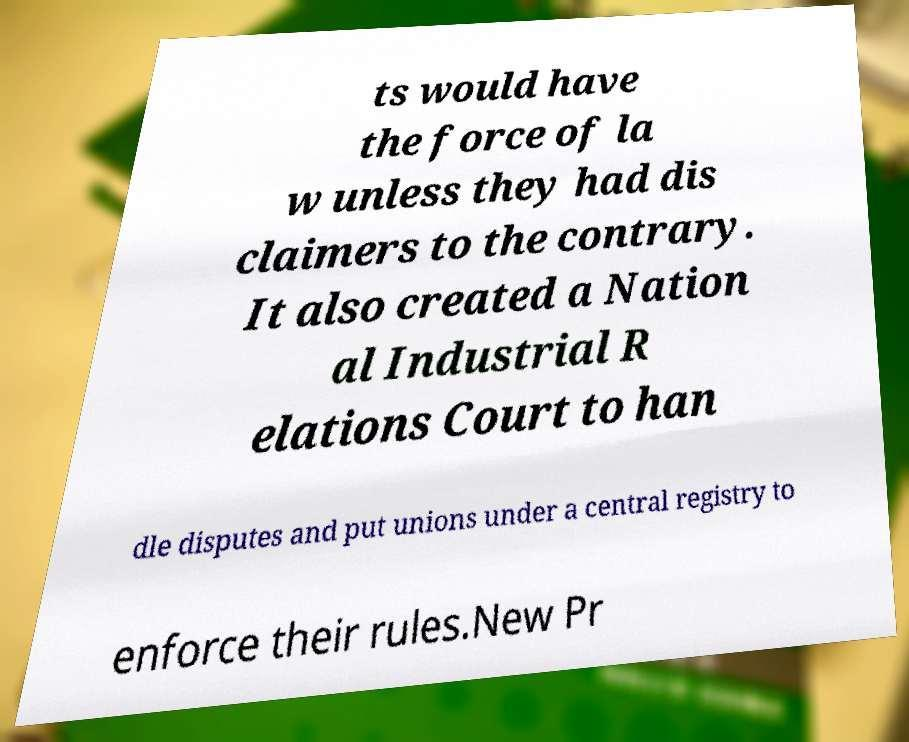Can you accurately transcribe the text from the provided image for me? ts would have the force of la w unless they had dis claimers to the contrary. It also created a Nation al Industrial R elations Court to han dle disputes and put unions under a central registry to enforce their rules.New Pr 